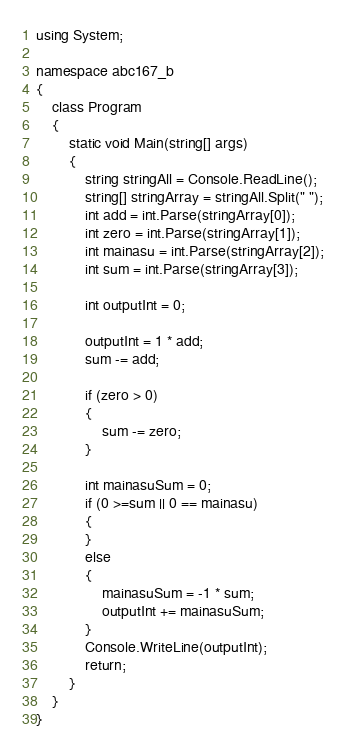<code> <loc_0><loc_0><loc_500><loc_500><_C#_>using System;

namespace abc167_b
{
    class Program
    {
        static void Main(string[] args)
        {
            string stringAll = Console.ReadLine();
            string[] stringArray = stringAll.Split(" ");
            int add = int.Parse(stringArray[0]);
            int zero = int.Parse(stringArray[1]);
            int mainasu = int.Parse(stringArray[2]);
            int sum = int.Parse(stringArray[3]);

            int outputInt = 0;

            outputInt = 1 * add;
            sum -= add;

            if (zero > 0)
            {
                sum -= zero;
            }

            int mainasuSum = 0;
            if (0 >=sum || 0 == mainasu)
            {
            }
            else
            {
                mainasuSum = -1 * sum;
                outputInt += mainasuSum;
            }
            Console.WriteLine(outputInt);
            return;
        }
    }
}
</code> 